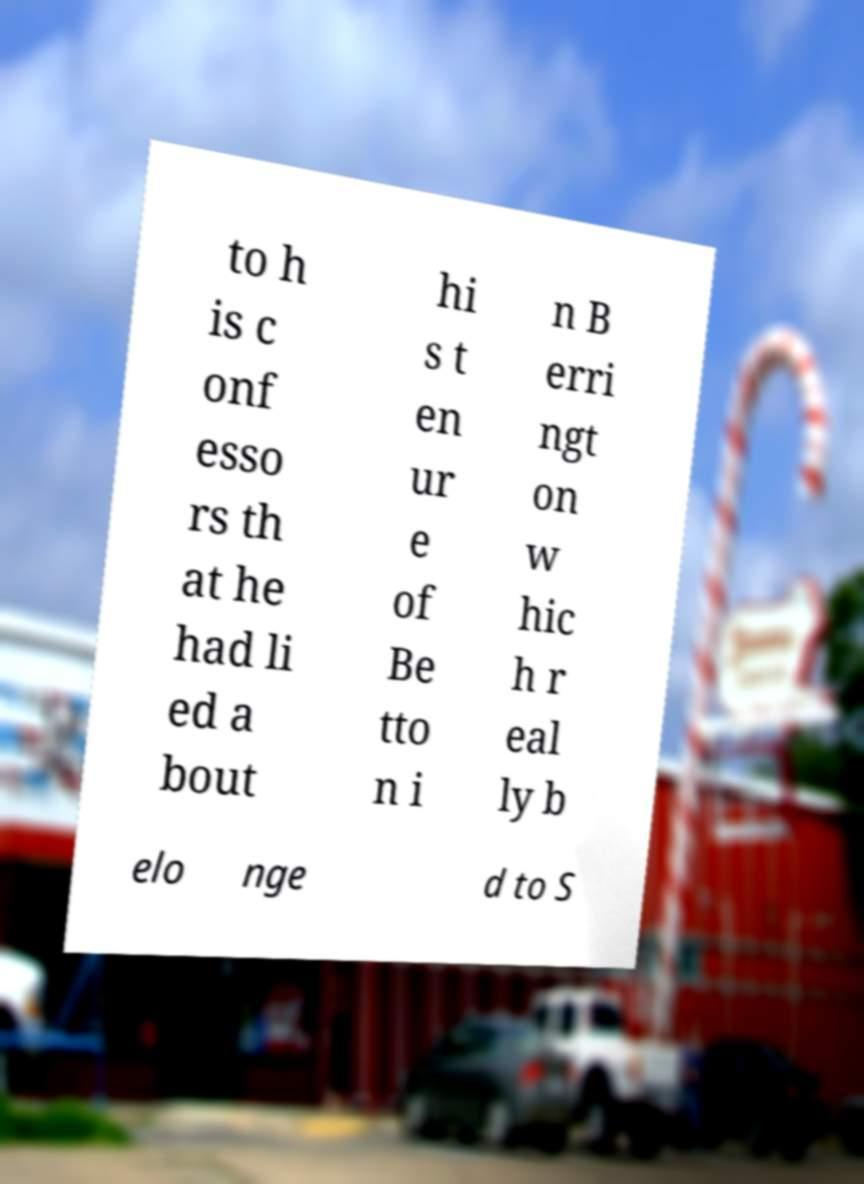What messages or text are displayed in this image? I need them in a readable, typed format. to h is c onf esso rs th at he had li ed a bout hi s t en ur e of Be tto n i n B erri ngt on w hic h r eal ly b elo nge d to S 